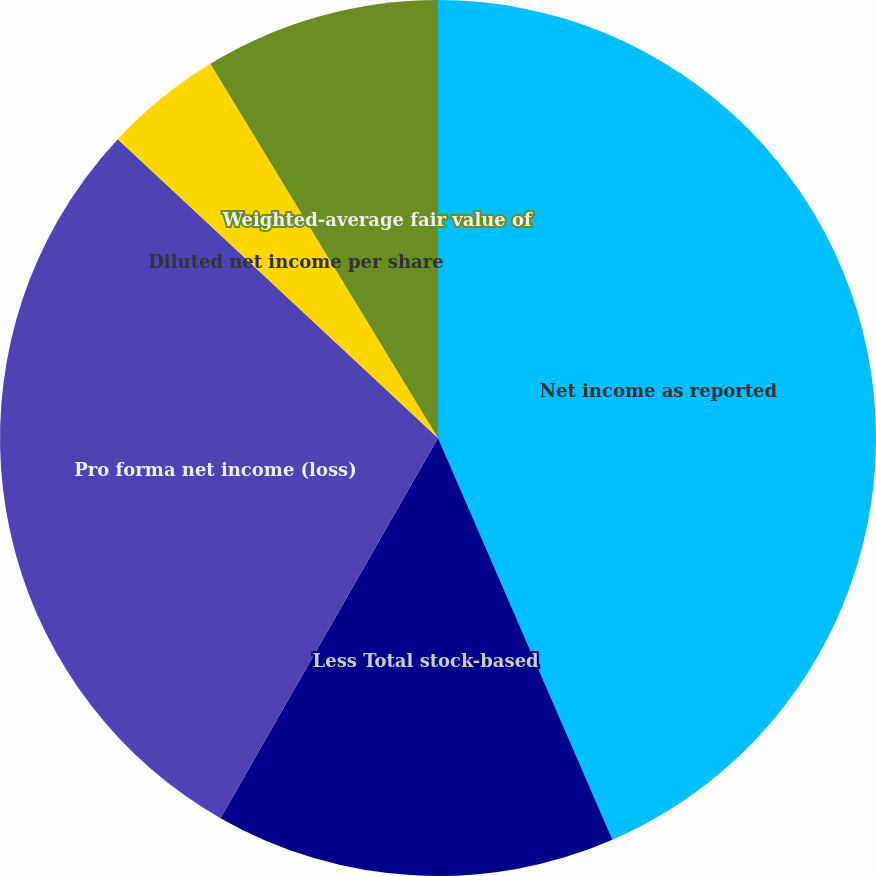Convert chart to OTSL. <chart><loc_0><loc_0><loc_500><loc_500><pie_chart><fcel>Net income as reported<fcel>Less Total stock-based<fcel>Pro forma net income (loss)<fcel>Diluted net income per share<fcel>Pro forma diluted net income<fcel>Weighted-average fair value of<nl><fcel>43.48%<fcel>14.79%<fcel>28.68%<fcel>4.35%<fcel>0.0%<fcel>8.7%<nl></chart> 